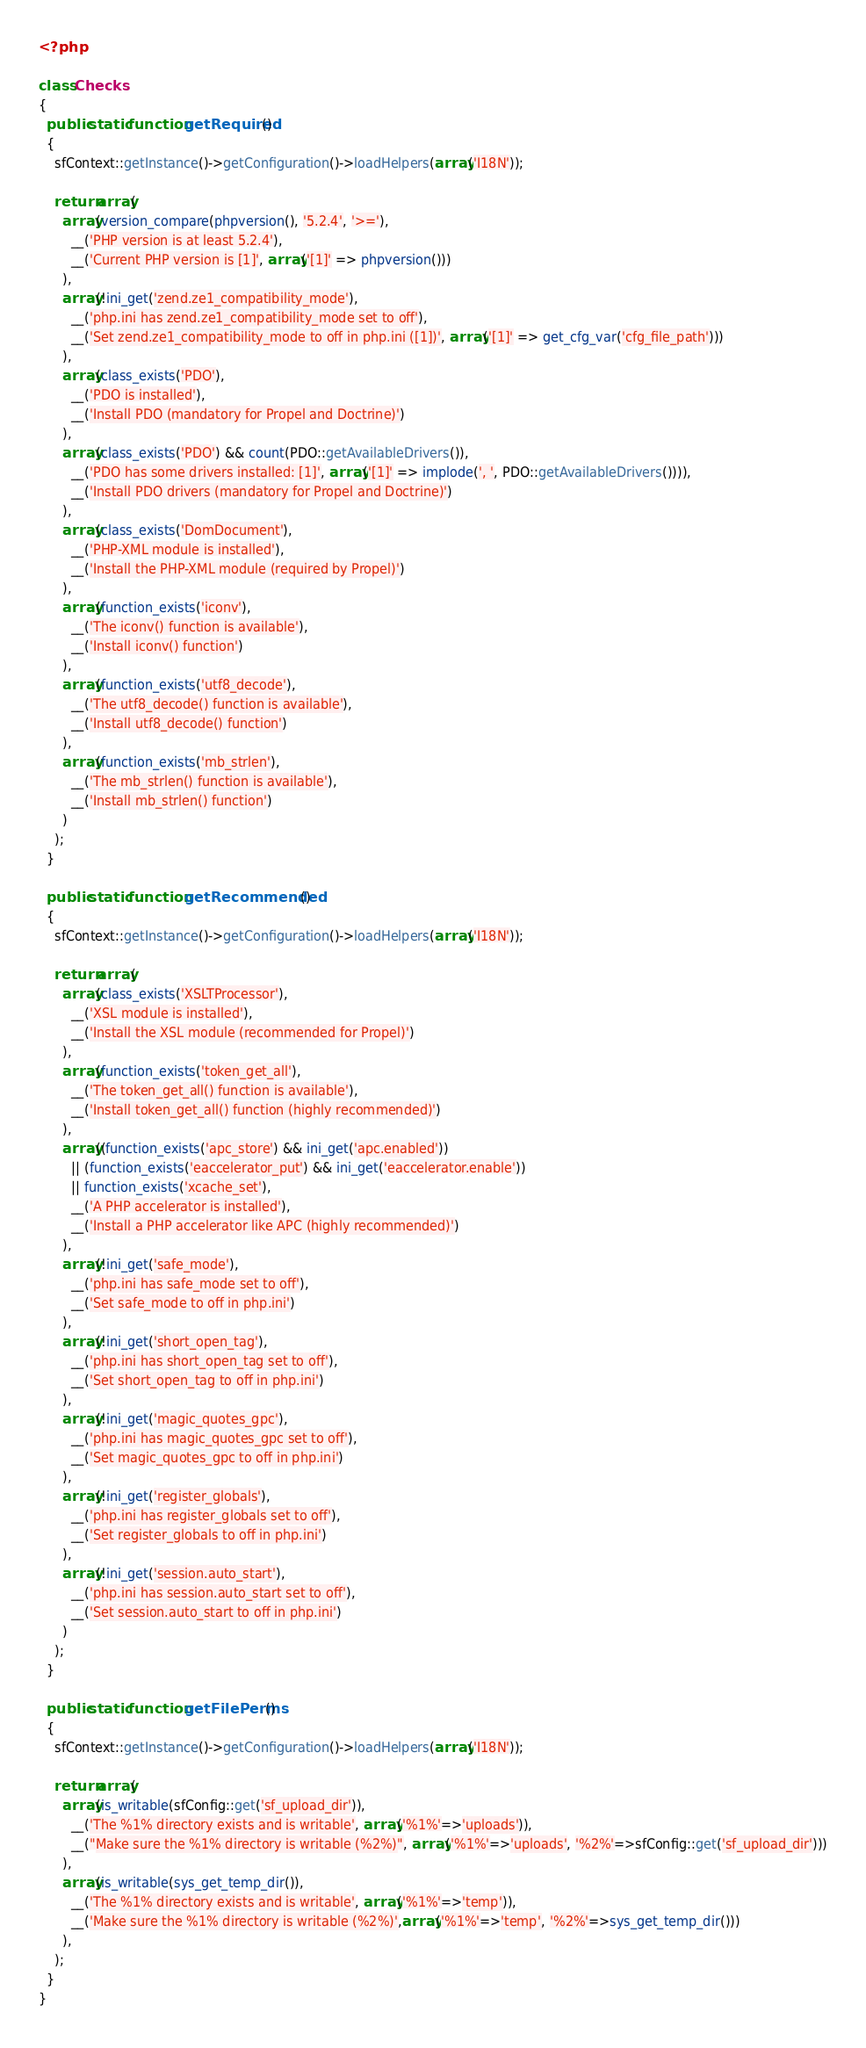Convert code to text. <code><loc_0><loc_0><loc_500><loc_500><_PHP_><?php

class Checks
{
  public static function getRequired()
  {
    sfContext::getInstance()->getConfiguration()->loadHelpers(array('I18N'));
    
    return array(
      array(version_compare(phpversion(), '5.2.4', '>='), 
        __('PHP version is at least 5.2.4'),
        __('Current PHP version is [1]', array('[1]' => phpversion()))
      ),
      array(!ini_get('zend.ze1_compatibility_mode'),
        __('php.ini has zend.ze1_compatibility_mode set to off'),
        __('Set zend.ze1_compatibility_mode to off in php.ini ([1])', array('[1]' => get_cfg_var('cfg_file_path')))
      ),
      array(class_exists('PDO'),
        __('PDO is installed'),
        __('Install PDO (mandatory for Propel and Doctrine)')
      ),
      array(class_exists('PDO') && count(PDO::getAvailableDrivers()),
        __('PDO has some drivers installed: [1]', array('[1]' => implode(', ', PDO::getAvailableDrivers()))),
        __('Install PDO drivers (mandatory for Propel and Doctrine)')
      ),
      array(class_exists('DomDocument'),
        __('PHP-XML module is installed'),
        __('Install the PHP-XML module (required by Propel)')
      ),
      array(function_exists('iconv'),
        __('The iconv() function is available'),
        __('Install iconv() function')
      ),
      array(function_exists('utf8_decode'),
        __('The utf8_decode() function is available'),
        __('Install utf8_decode() function')
      ),
      array(function_exists('mb_strlen'),
        __('The mb_strlen() function is available'),
        __('Install mb_strlen() function')
      )
    );
  }
  
  public static function getRecommended()
  {
    sfContext::getInstance()->getConfiguration()->loadHelpers(array('I18N'));
    
    return array(
      array(class_exists('XSLTProcessor'),
        __('XSL module is installed'),
        __('Install the XSL module (recommended for Propel)')
      ),
      array(function_exists('token_get_all'),
        __('The token_get_all() function is available'),
        __('Install token_get_all() function (highly recommended)')
      ),
      array((function_exists('apc_store') && ini_get('apc.enabled'))
        || (function_exists('eaccelerator_put') && ini_get('eaccelerator.enable'))
        || function_exists('xcache_set'),
        __('A PHP accelerator is installed'),
        __('Install a PHP accelerator like APC (highly recommended)')
      ),
      array(!ini_get('safe_mode'),
        __('php.ini has safe_mode set to off'),
        __('Set safe_mode to off in php.ini')
      ),
      array(!ini_get('short_open_tag'),
        __('php.ini has short_open_tag set to off'),
        __('Set short_open_tag to off in php.ini')
      ),
      array(!ini_get('magic_quotes_gpc'),
        __('php.ini has magic_quotes_gpc set to off'),
        __('Set magic_quotes_gpc to off in php.ini')
      ),
      array(!ini_get('register_globals'),
        __('php.ini has register_globals set to off'),
        __('Set register_globals to off in php.ini')
      ),
      array(!ini_get('session.auto_start'),
        __('php.ini has session.auto_start set to off'),
        __('Set session.auto_start to off in php.ini')
      )
    );
  }
  
  public static function getFilePerms()
  {
    sfContext::getInstance()->getConfiguration()->loadHelpers(array('I18N'));
    
    return array(
      array(is_writable(sfConfig::get('sf_upload_dir')),
        __('The %1% directory exists and is writable', array('%1%'=>'uploads')),
        __("Make sure the %1% directory is writable (%2%)", array('%1%'=>'uploads', '%2%'=>sfConfig::get('sf_upload_dir')))
      ),
      array(is_writable(sys_get_temp_dir()),
        __('The %1% directory exists and is writable', array('%1%'=>'temp')),
        __('Make sure the %1% directory is writable (%2%)',array('%1%'=>'temp', '%2%'=>sys_get_temp_dir()))
      ),
    );
  }
}</code> 